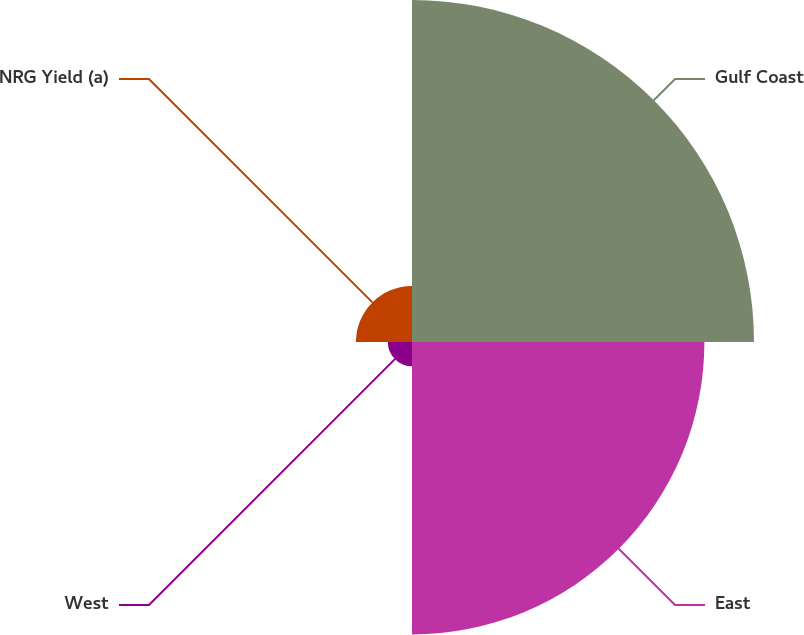Convert chart. <chart><loc_0><loc_0><loc_500><loc_500><pie_chart><fcel>Gulf Coast<fcel>East<fcel>West<fcel>NRG Yield (a)<nl><fcel>47.86%<fcel>40.92%<fcel>3.39%<fcel>7.84%<nl></chart> 